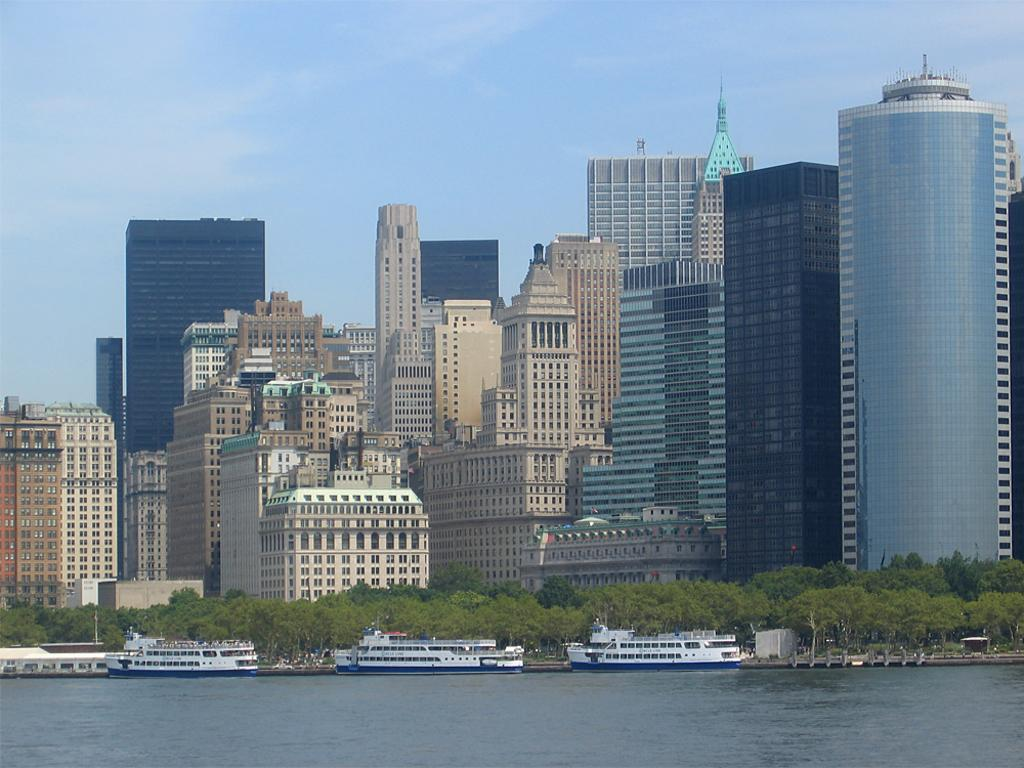What body of water is present in the image? There is a river in the image. What is happening in the river? There are boats sailing in the river. What can be seen in the background of the image? There are trees and buildings with glass windows in the backdrop of the image. How would you describe the sky in the image? The sky is clear in the image. What type of fuel is being used by the boats in the image? The image does not provide information about the type of fuel being used by the boats. Can you see a badge on any of the trees in the image? There are no badges visible on the trees in the image. 